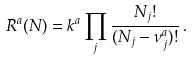<formula> <loc_0><loc_0><loc_500><loc_500>R ^ { a } ( N ) = k ^ { a } \prod _ { j } \frac { N _ { j } ! } { ( N _ { j } - \nu _ { j } ^ { a } ) ! } \, .</formula> 